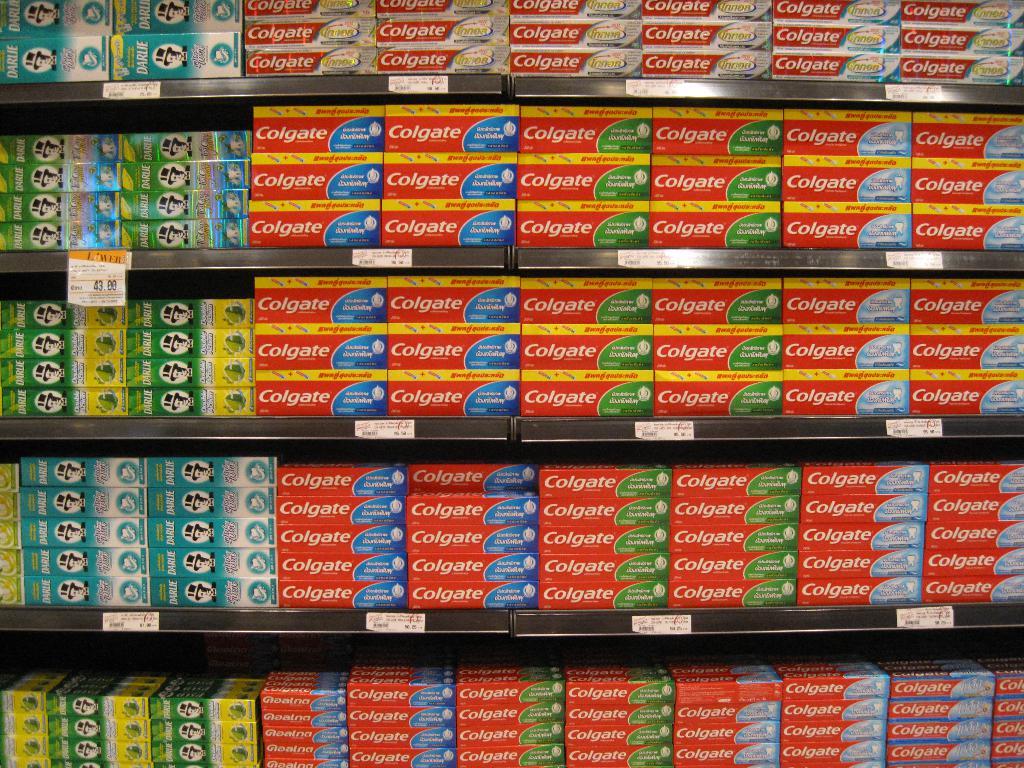What brand of toothpaste is this?
Provide a succinct answer. Colgate. Are these different types of colgate toothpaste?
Provide a succinct answer. Yes. 